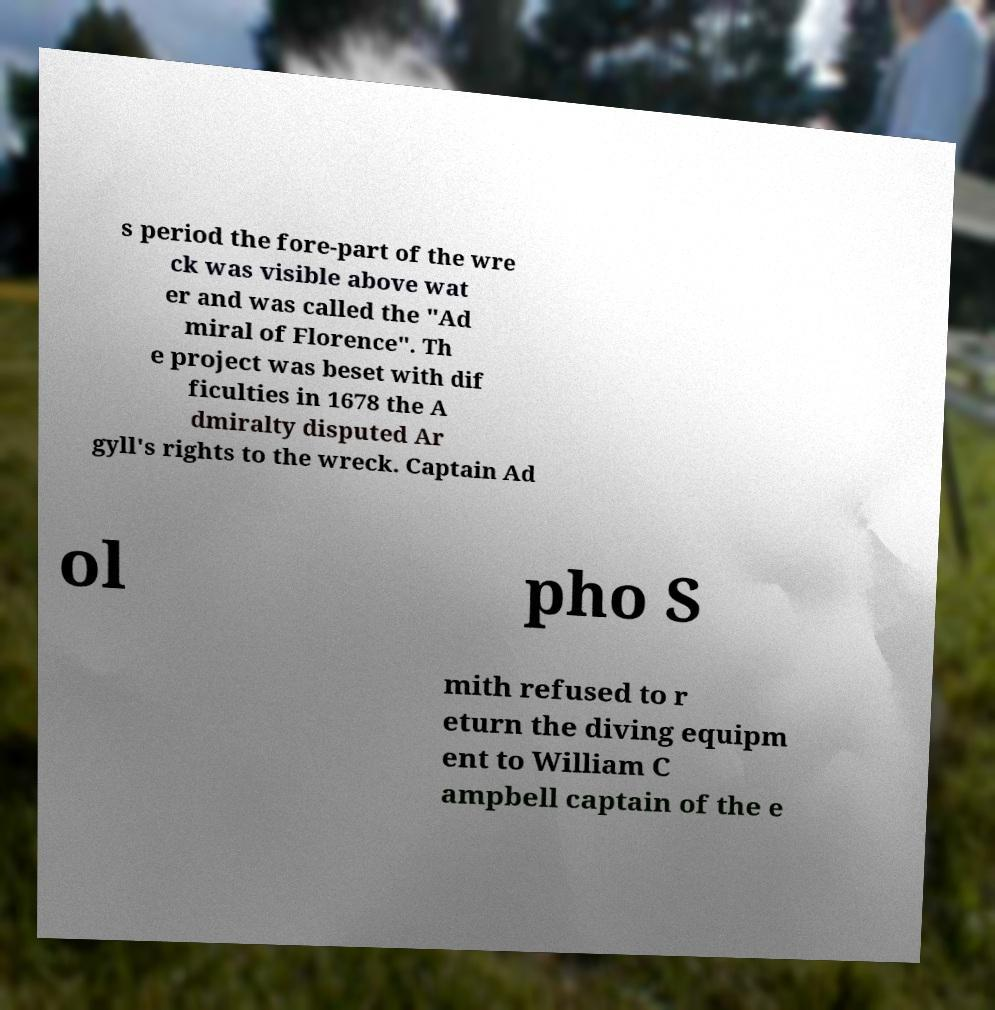Please read and relay the text visible in this image. What does it say? s period the fore-part of the wre ck was visible above wat er and was called the "Ad miral of Florence". Th e project was beset with dif ficulties in 1678 the A dmiralty disputed Ar gyll's rights to the wreck. Captain Ad ol pho S mith refused to r eturn the diving equipm ent to William C ampbell captain of the e 